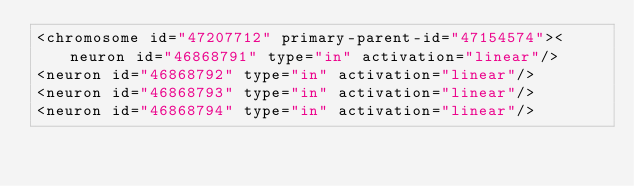Convert code to text. <code><loc_0><loc_0><loc_500><loc_500><_XML_><chromosome id="47207712" primary-parent-id="47154574"><neuron id="46868791" type="in" activation="linear"/>
<neuron id="46868792" type="in" activation="linear"/>
<neuron id="46868793" type="in" activation="linear"/>
<neuron id="46868794" type="in" activation="linear"/></code> 